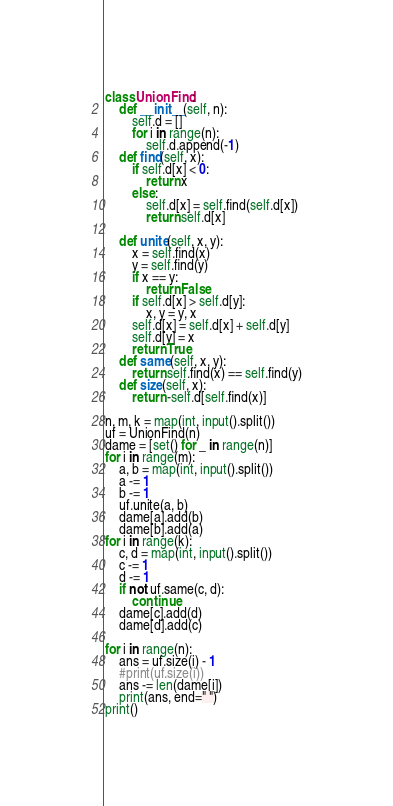Convert code to text. <code><loc_0><loc_0><loc_500><loc_500><_Python_>class UnionFind:
    def __init__(self, n):
        self.d = []
        for i in range(n):
            self.d.append(-1)
    def find(self, x):
        if self.d[x] < 0:
            return x
        else:
            self.d[x] = self.find(self.d[x])
            return self.d[x]
    
    def unite(self, x, y):
        x = self.find(x)
        y = self.find(y)
        if x == y:
            return False
        if self.d[x] > self.d[y]:
            x, y = y, x
        self.d[x] = self.d[x] + self.d[y]
        self.d[y] = x
        return True
    def same(self, x, y):
        return self.find(x) == self.find(y)
    def size(self, x):
        return -self.d[self.find(x)]
    
n, m, k = map(int, input().split())
uf = UnionFind(n)
dame = [set() for _ in range(n)]
for i in range(m):
    a, b = map(int, input().split())
    a -= 1
    b -= 1
    uf.unite(a, b)
    dame[a].add(b)
    dame[b].add(a)
for i in range(k):
    c, d = map(int, input().split())
    c -= 1
    d -= 1
    if not uf.same(c, d):
        continue
    dame[c].add(d)
    dame[d].add(c)

for i in range(n):
    ans = uf.size(i) - 1
    #print(uf.size(i))
    ans -= len(dame[i])
    print(ans, end=" ")
print()</code> 